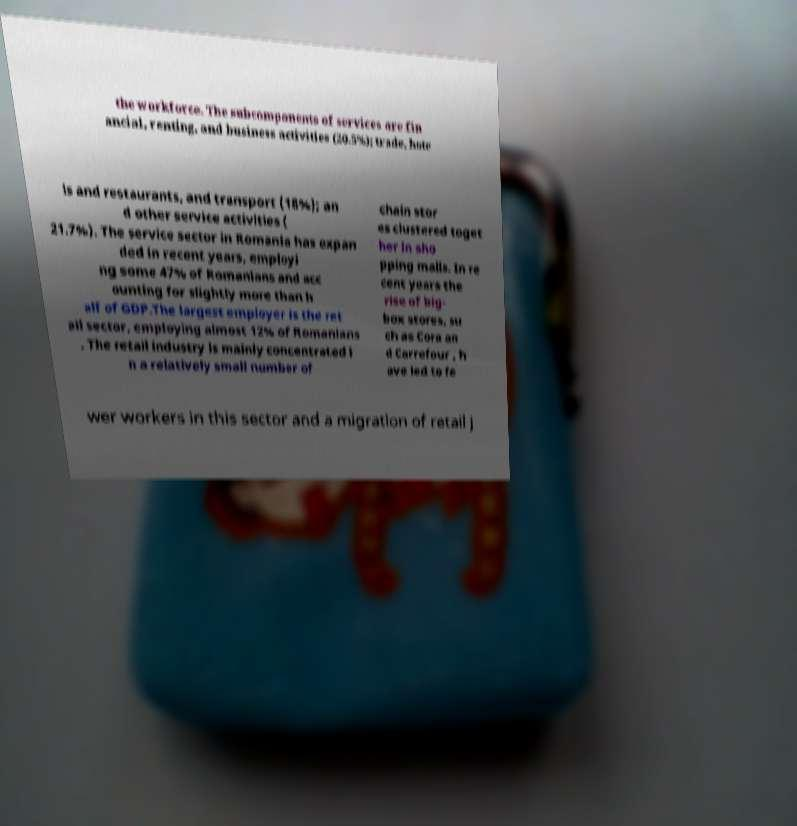I need the written content from this picture converted into text. Can you do that? the workforce. The subcomponents of services are fin ancial, renting, and business activities (20.5%); trade, hote ls and restaurants, and transport (18%); an d other service activities ( 21.7%). The service sector in Romania has expan ded in recent years, employi ng some 47% of Romanians and acc ounting for slightly more than h alf of GDP.The largest employer is the ret ail sector, employing almost 12% of Romanians . The retail industry is mainly concentrated i n a relatively small number of chain stor es clustered toget her in sho pping malls. In re cent years the rise of big- box stores, su ch as Cora an d Carrefour , h ave led to fe wer workers in this sector and a migration of retail j 